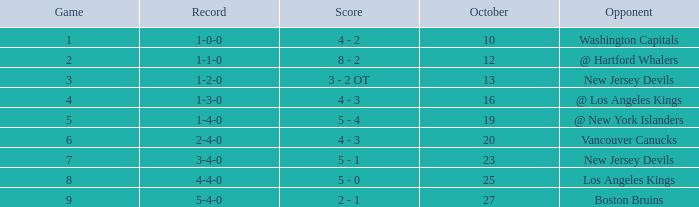What was the average game with a record of 4-4-0? 8.0. 